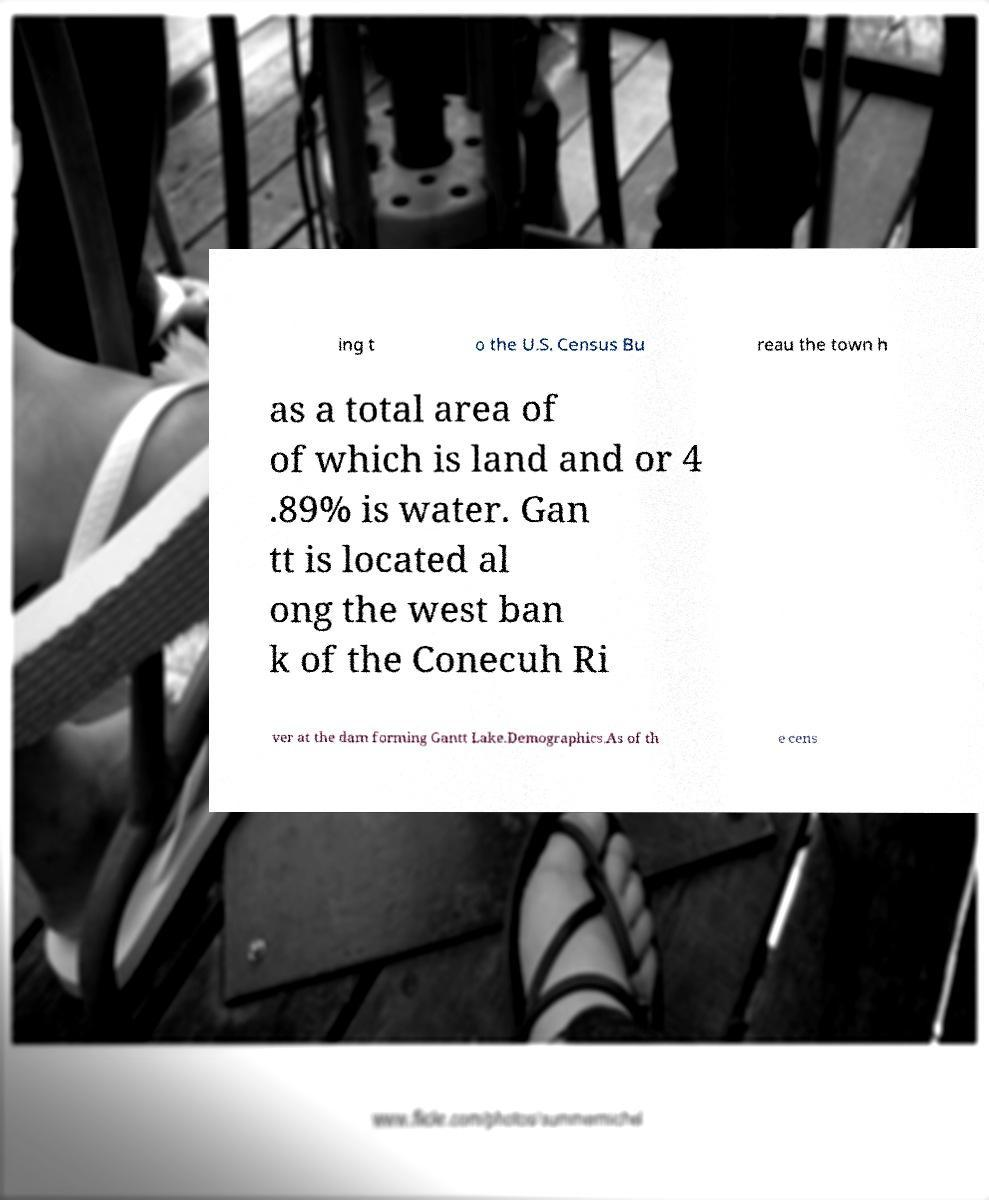Please read and relay the text visible in this image. What does it say? ing t o the U.S. Census Bu reau the town h as a total area of of which is land and or 4 .89% is water. Gan tt is located al ong the west ban k of the Conecuh Ri ver at the dam forming Gantt Lake.Demographics.As of th e cens 